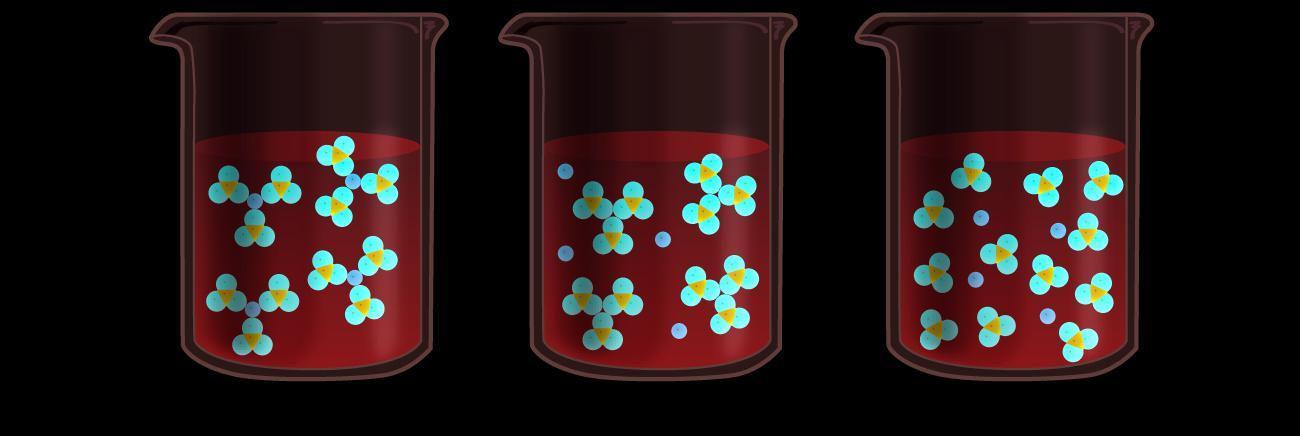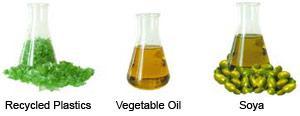The first image is the image on the left, the second image is the image on the right. Assess this claim about the two images: "All images show beakers and all beakers contain colored liquids.". Correct or not? Answer yes or no. No. The first image is the image on the left, the second image is the image on the right. Examine the images to the left and right. Is the description "There are no more than 5 laboratory flasks in the pair of images." accurate? Answer yes or no. No. 